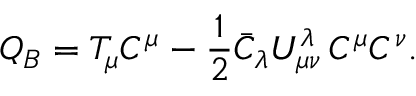<formula> <loc_0><loc_0><loc_500><loc_500>Q _ { B } = T _ { \mu } C ^ { \mu } - \frac { 1 } { 2 } \bar { C } _ { \lambda } U _ { \mu \nu } ^ { \lambda } \, C ^ { \mu } C ^ { \nu } .</formula> 